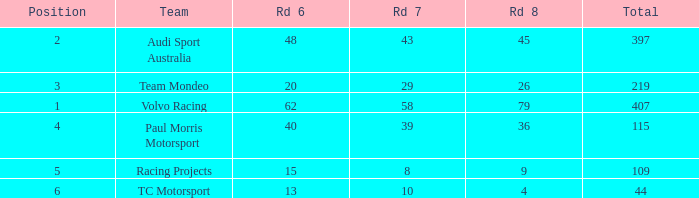What is the average value for Rd 8 in a position less than 2 for Audi Sport Australia? None. 